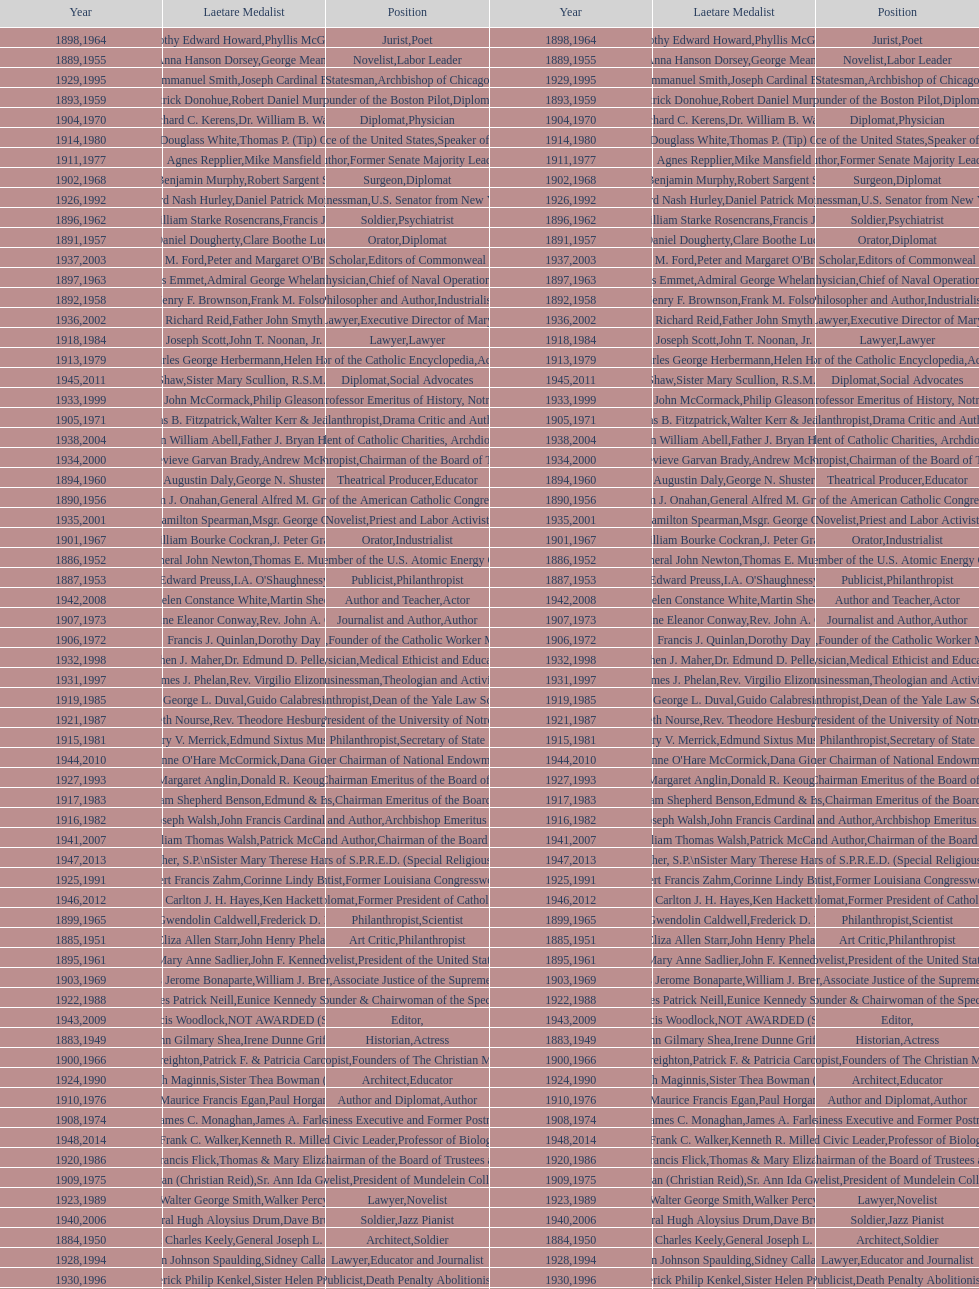What are the total number of times soldier is listed as the position on this chart? 4. Give me the full table as a dictionary. {'header': ['Year', 'Laetare Medalist', 'Position', 'Year', 'Laetare Medalist', 'Position'], 'rows': [['1898', 'Timothy Edward Howard', 'Jurist', '1964', 'Phyllis McGinley', 'Poet'], ['1889', 'Anna Hanson Dorsey', 'Novelist', '1955', 'George Meany', 'Labor Leader'], ['1929', 'Alfred Emmanuel Smith', 'Statesman', '1995', 'Joseph Cardinal Bernardin', 'Archbishop of Chicago'], ['1893', 'Patrick Donohue', 'Founder of the Boston Pilot', '1959', 'Robert Daniel Murphy', 'Diplomat'], ['1904', 'Richard C. Kerens', 'Diplomat', '1970', 'Dr. William B. Walsh', 'Physician'], ['1914', 'Edward Douglass White', 'Chief Justice of the United States', '1980', "Thomas P. (Tip) O'Neill Jr.", 'Speaker of the House'], ['1911', 'Agnes Repplier', 'Author', '1977', 'Mike Mansfield', 'Former Senate Majority Leader'], ['1902', 'John Benjamin Murphy', 'Surgeon', '1968', 'Robert Sargent Shriver', 'Diplomat'], ['1926', 'Edward Nash Hurley', 'Businessman', '1992', 'Daniel Patrick Moynihan', 'U.S. Senator from New York'], ['1896', 'General William Starke Rosencrans', 'Soldier', '1962', 'Francis J. Braceland', 'Psychiatrist'], ['1891', 'Daniel Dougherty', 'Orator', '1957', 'Clare Boothe Luce', 'Diplomat'], ['1937', 'Jeremiah D. M. Ford', 'Scholar', '2003', "Peter and Margaret O'Brien Steinfels", 'Editors of Commonweal'], ['1897', 'Thomas Addis Emmet', 'Physician', '1963', 'Admiral George Whelan Anderson, Jr.', 'Chief of Naval Operations'], ['1892', 'Henry F. Brownson', 'Philosopher and Author', '1958', 'Frank M. Folsom', 'Industrialist'], ['1936', 'Richard Reid', 'Journalist and Lawyer', '2002', 'Father John Smyth', 'Executive Director of Maryville Academy'], ['1918', 'Joseph Scott', 'Lawyer', '1984', 'John T. Noonan, Jr.', 'Lawyer'], ['1913', 'Charles George Herbermann', 'Editor of the Catholic Encyclopedia', '1979', 'Helen Hayes', 'Actress'], ['1945', 'Gardiner Howland Shaw', 'Diplomat', '2011', 'Sister Mary Scullion, R.S.M., & Joan McConnon', 'Social Advocates'], ['1933', 'John McCormack', 'Artist', '1999', 'Philip Gleason', 'Professor Emeritus of History, Notre Dame'], ['1905', 'Thomas B. Fitzpatrick', 'Philanthropist', '1971', 'Walter Kerr & Jean Kerr', 'Drama Critic and Author'], ['1938', 'Irvin William Abell', 'Surgeon', '2004', 'Father J. Bryan Hehir', 'President of Catholic Charities, Archdiocese of Boston'], ['1934', 'Genevieve Garvan Brady', 'Philanthropist', '2000', 'Andrew McKenna', 'Chairman of the Board of Trustees'], ['1894', 'Augustin Daly', 'Theatrical Producer', '1960', 'George N. Shuster', 'Educator'], ['1890', 'William J. Onahan', 'Organizer of the American Catholic Congress', '1956', 'General Alfred M. Gruenther', 'Soldier'], ['1935', 'Francis Hamilton Spearman', 'Novelist', '2001', 'Msgr. George G. Higgins', 'Priest and Labor Activist'], ['1901', 'William Bourke Cockran', 'Orator', '1967', 'J. Peter Grace', 'Industrialist'], ['1886', 'General John Newton', 'Engineer', '1952', 'Thomas E. Murray', 'Member of the U.S. Atomic Energy Commission'], ['1887', 'Edward Preuss', 'Publicist', '1953', "I.A. O'Shaughnessy", 'Philanthropist'], ['1942', 'Helen Constance White', 'Author and Teacher', '2008', 'Martin Sheen', 'Actor'], ['1907', 'Katherine Eleanor Conway', 'Journalist and Author', '1973', "Rev. John A. O'Brien", 'Author'], ['1906', 'Francis J. Quinlan', 'Physician', '1972', 'Dorothy Day', 'Founder of the Catholic Worker Movement'], ['1932', 'Stephen J. Maher', 'Physician', '1998', 'Dr. Edmund D. Pellegrino', 'Medical Ethicist and Educator'], ['1931', 'James J. Phelan', 'Businessman', '1997', 'Rev. Virgilio Elizondo', 'Theologian and Activist'], ['1919', 'George L. Duval', 'Philanthropist', '1985', 'Guido Calabresi', 'Dean of the Yale Law School'], ['1921', 'Elizabeth Nourse', 'Artist', '1987', 'Rev. Theodore Hesburgh, CSC', 'President of the University of Notre Dame'], ['1915', 'Mary V. Merrick', 'Philanthropist', '1981', 'Edmund Sixtus Muskie', 'Secretary of State'], ['1944', "Anne O'Hare McCormick", 'Journalist', '2010', 'Dana Gioia', 'Former Chairman of National Endowment for the Arts'], ['1927', 'Margaret Anglin', 'Actress', '1993', 'Donald R. Keough', 'Chairman Emeritus of the Board of Trustees'], ['1917', 'Admiral William Shepherd Benson', 'Chief of Naval Operations', '1983', 'Edmund & Evelyn Stephan', 'Chairman Emeritus of the Board of Trustees and his wife'], ['1916', 'James Joseph Walsh', 'Physician and Author', '1982', 'John Francis Cardinal Dearden', 'Archbishop Emeritus of Detroit'], ['1941', 'William Thomas Walsh', 'Journalist and Author', '2007', 'Patrick McCartan', 'Chairman of the Board of Trustees'], ['1947', 'William G. Bruce', 'Publisher and Civic Leader', '2013', 'Sister Susanne Gallagher, S.P.\\nSister Mary Therese Harrington, S.H.\\nRev. James H. McCarthy', 'Founders of S.P.R.E.D. (Special Religious Education Development Network)'], ['1925', 'Albert Francis Zahm', 'Scientist', '1991', 'Corinne Lindy Boggs', 'Former Louisiana Congresswoman'], ['1946', 'Carlton J. H. Hayes', 'Historian and Diplomat', '2012', 'Ken Hackett', 'Former President of Catholic Relief Services'], ['1899', 'Mary Gwendolin Caldwell', 'Philanthropist', '1965', 'Frederick D. Rossini', 'Scientist'], ['1885', 'Eliza Allen Starr', 'Art Critic', '1951', 'John Henry Phelan', 'Philanthropist'], ['1895', 'Mary Anne Sadlier', 'Novelist', '1961', 'John F. Kennedy', 'President of the United States'], ['1903', 'Charles Jerome Bonaparte', 'Lawyer', '1969', 'William J. Brennan Jr.', 'Associate Justice of the Supreme Court'], ['1922', 'Charles Patrick Neill', 'Economist', '1988', 'Eunice Kennedy Shriver', 'Founder & Chairwoman of the Special Olympics'], ['1943', 'Thomas Francis Woodlock', 'Editor', '2009', 'NOT AWARDED (SEE BELOW)', ''], ['1883', 'John Gilmary Shea', 'Historian', '1949', 'Irene Dunne Griffin', 'Actress'], ['1900', 'John A. Creighton', 'Philanthropist', '1966', 'Patrick F. & Patricia Caron Crowley', 'Founders of The Christian Movement'], ['1924', 'Charles Donagh Maginnis', 'Architect', '1990', 'Sister Thea Bowman (posthumously)', 'Educator'], ['1910', 'Maurice Francis Egan', 'Author and Diplomat', '1976', 'Paul Horgan', 'Author'], ['1908', 'James C. Monaghan', 'Economist', '1974', 'James A. Farley', 'Business Executive and Former Postmaster General'], ['1948', 'Frank C. Walker', 'Postmaster General and Civic Leader', '2014', 'Kenneth R. Miller', 'Professor of Biology at Brown University'], ['1920', 'Lawrence Francis Flick', 'Physician', '1986', 'Thomas & Mary Elizabeth Carney', 'Chairman of the Board of Trustees and his wife'], ['1909', 'Frances Tieran (Christian Reid)', 'Novelist', '1975', 'Sr. Ann Ida Gannon, BMV', 'President of Mundelein College'], ['1923', 'Walter George Smith', 'Lawyer', '1989', 'Walker Percy', 'Novelist'], ['1940', 'General Hugh Aloysius Drum', 'Soldier', '2006', 'Dave Brubeck', 'Jazz Pianist'], ['1884', 'Patrick Charles Keely', 'Architect', '1950', 'General Joseph L. Collins', 'Soldier'], ['1928', 'John Johnson Spaulding', 'Lawyer', '1994', 'Sidney Callahan', 'Educator and Journalist'], ['1930', 'Frederick Philip Kenkel', 'Publicist', '1996', 'Sister Helen Prejean', 'Death Penalty Abolitionist'], ['1888', 'Patrick V. Hickey', 'Founder and Editor of The Catholic Review', '1954', 'Jefferson Caffery', 'Diplomat'], ['1912', 'Thomas M. Mulry', 'Philanthropist', '1978', 'Msgr. John Tracy Ellis', 'Church Historian'], ['1939', 'Josephine Van Dyke Brownson', 'Catechist', '2005', 'Dr. Joseph E. Murray', 'Surgeon & Nobel Prize Winner']]} 